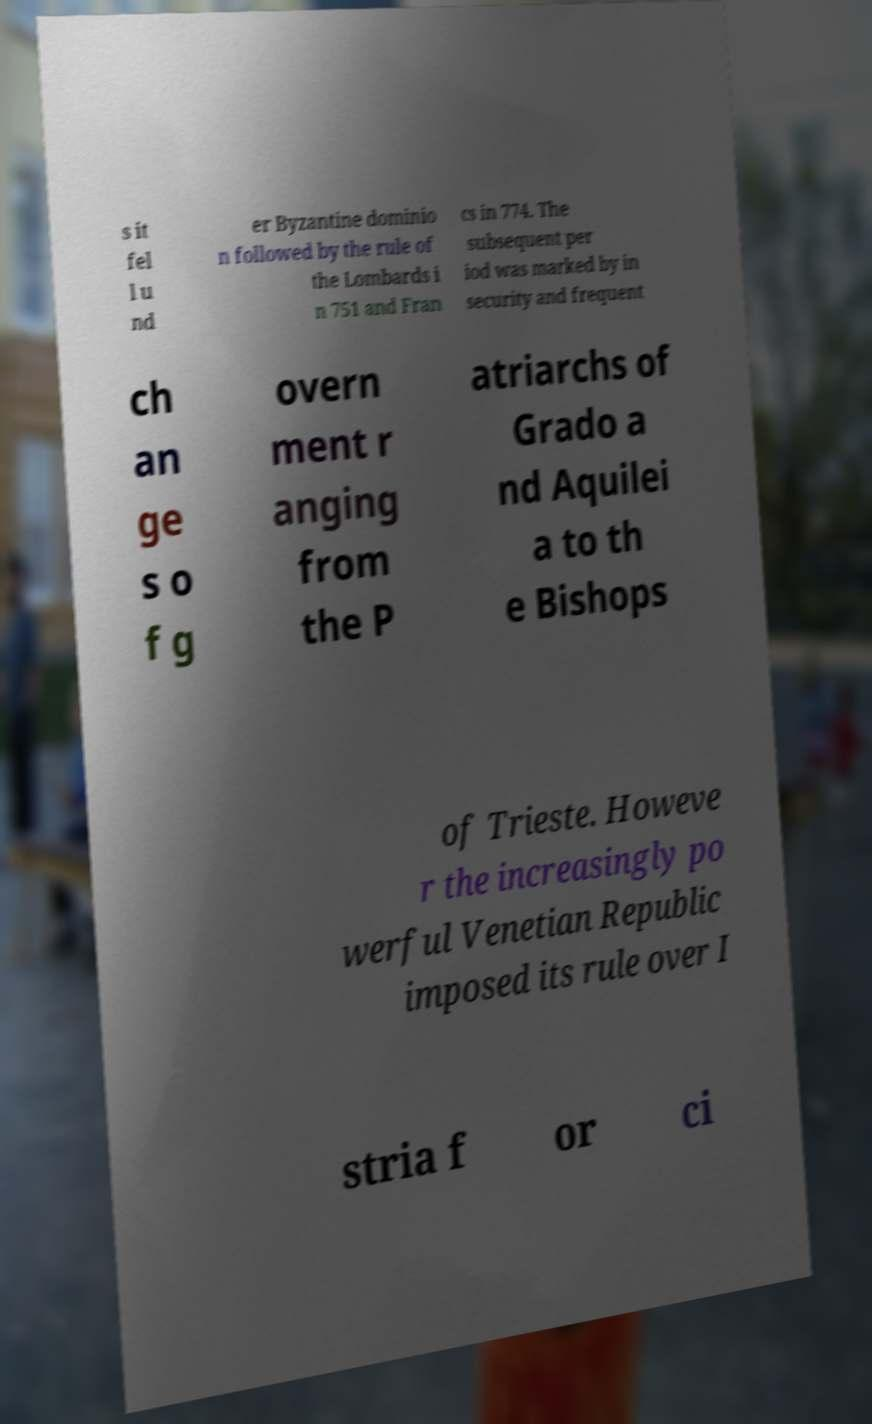Can you accurately transcribe the text from the provided image for me? s it fel l u nd er Byzantine dominio n followed by the rule of the Lombards i n 751 and Fran cs in 774. The subsequent per iod was marked by in security and frequent ch an ge s o f g overn ment r anging from the P atriarchs of Grado a nd Aquilei a to th e Bishops of Trieste. Howeve r the increasingly po werful Venetian Republic imposed its rule over I stria f or ci 